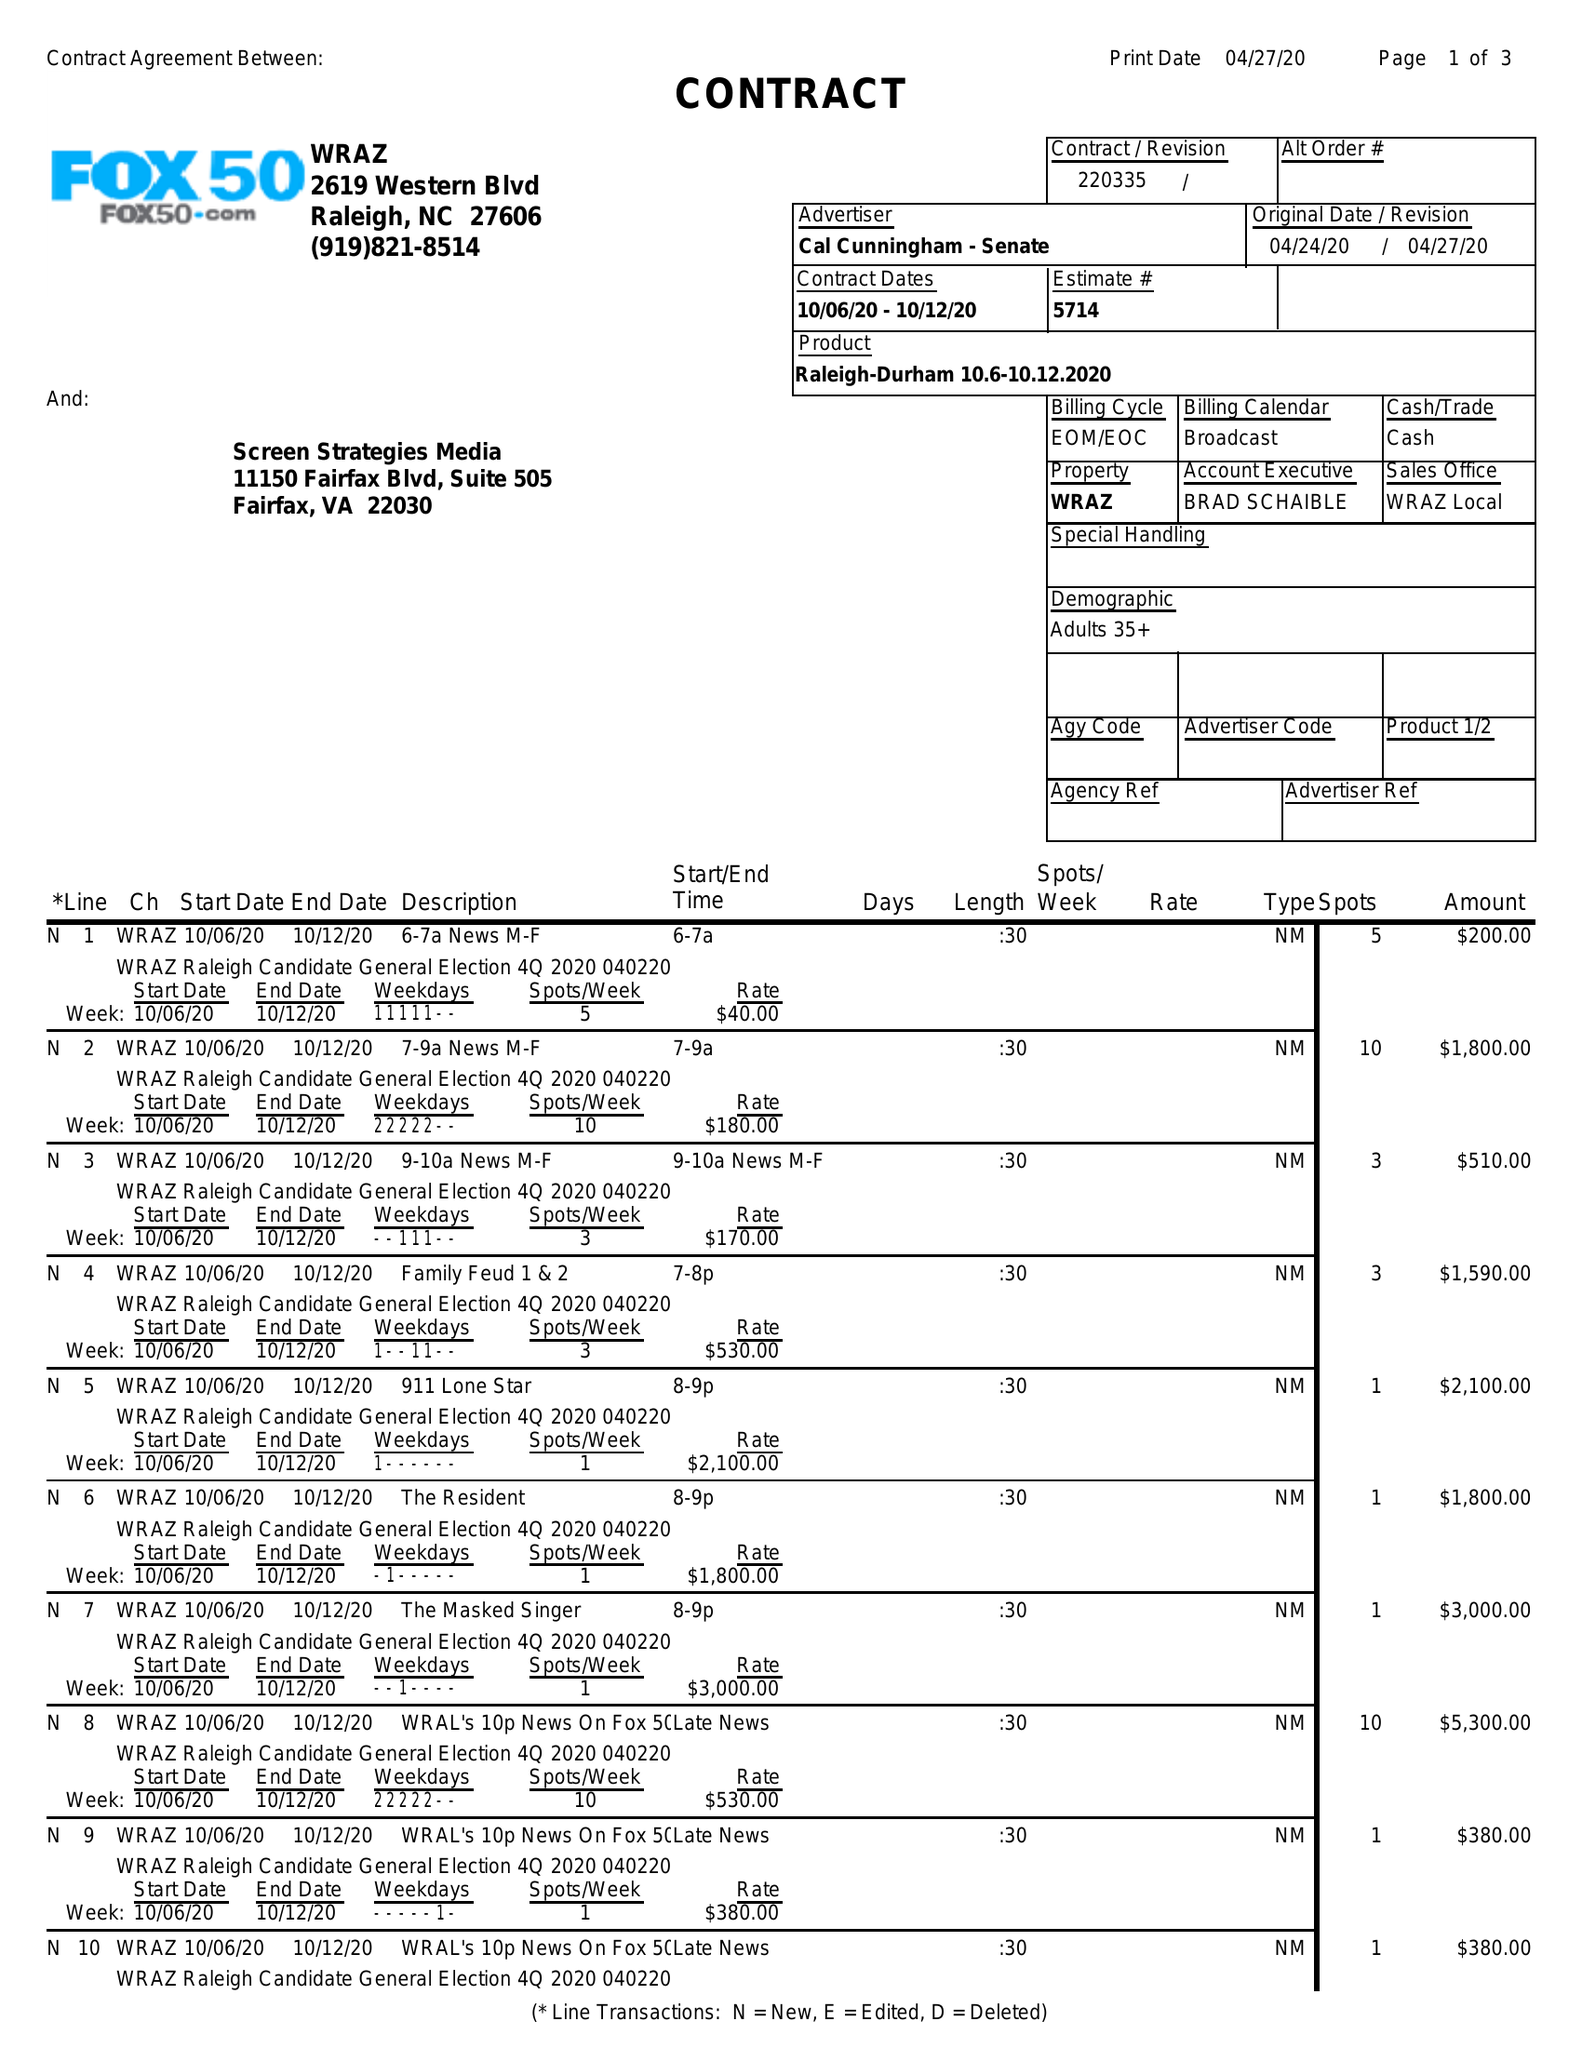What is the value for the flight_to?
Answer the question using a single word or phrase. 10/12/20 